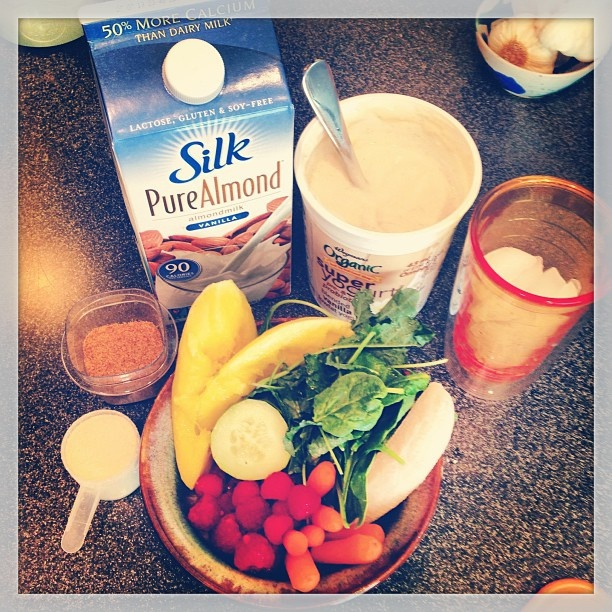Describe the objects in this image and their specific colors. I can see cup in lightgray, tan, beige, and gray tones, sandwich in lightgray, khaki, navy, olive, and teal tones, cup in lightgray, brown, tan, and salmon tones, carrot in lightgray, brown, salmon, and navy tones, and bowl in lightgray, tan, salmon, and navy tones in this image. 